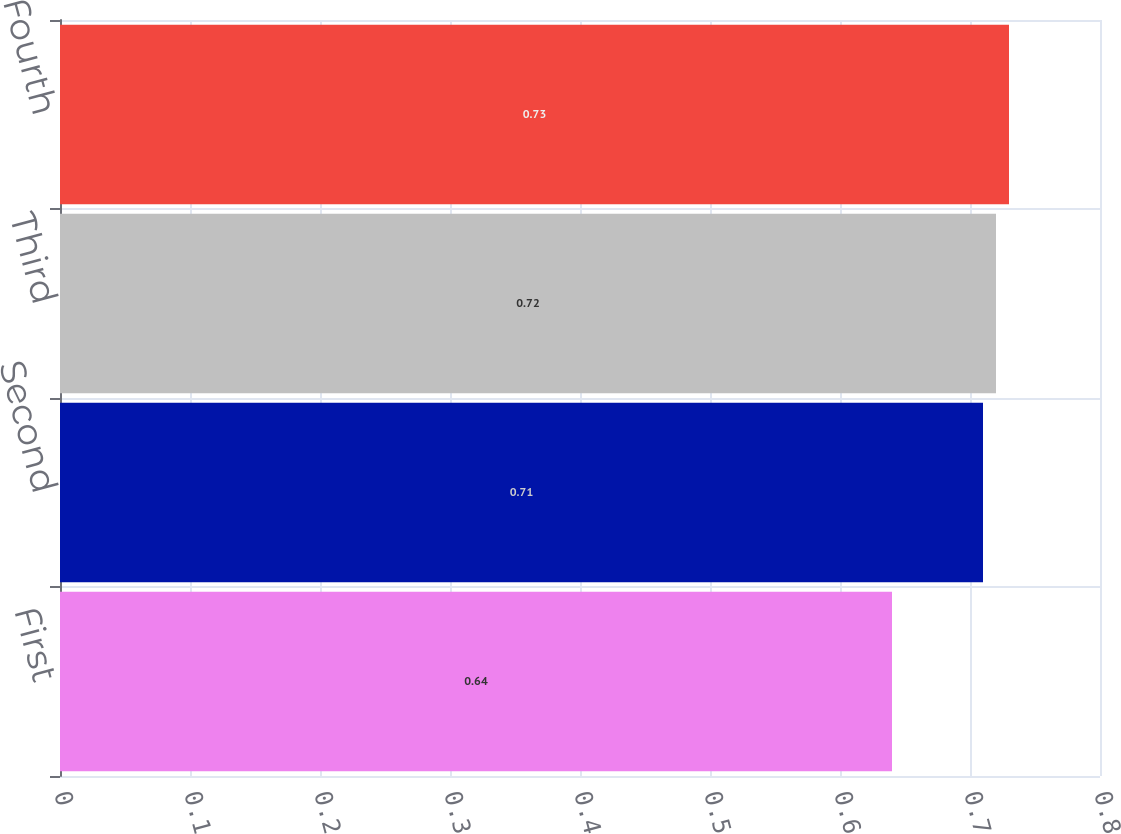Convert chart to OTSL. <chart><loc_0><loc_0><loc_500><loc_500><bar_chart><fcel>First<fcel>Second<fcel>Third<fcel>Fourth<nl><fcel>0.64<fcel>0.71<fcel>0.72<fcel>0.73<nl></chart> 